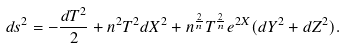<formula> <loc_0><loc_0><loc_500><loc_500>d s ^ { 2 } = - \frac { d T ^ { 2 } } { 2 } + n ^ { 2 } T ^ { 2 } d X ^ { 2 } + n ^ { \frac { 2 } { n } } T ^ { \frac { 2 } { n } } e ^ { 2 X } ( d Y ^ { 2 } + d Z ^ { 2 } ) .</formula> 